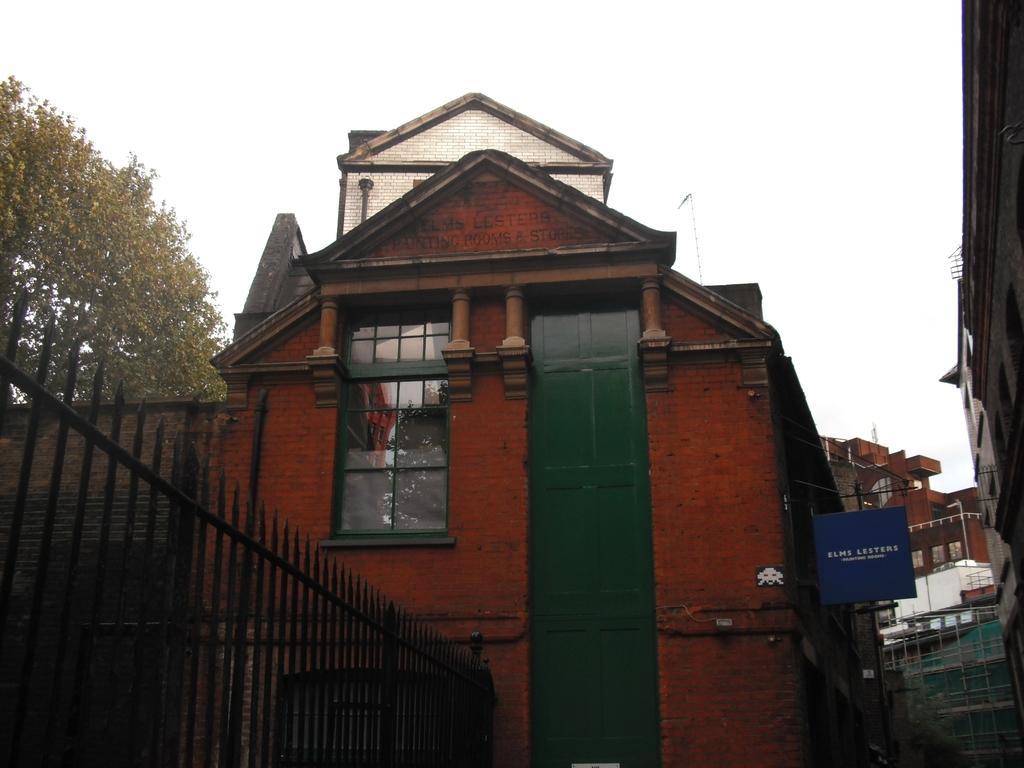In one or two sentences, can you explain what this image depicts? On the left side, there is a black color fencing, near a building which is having glass windows. In the background, there are buildings, trees and there is sky. 